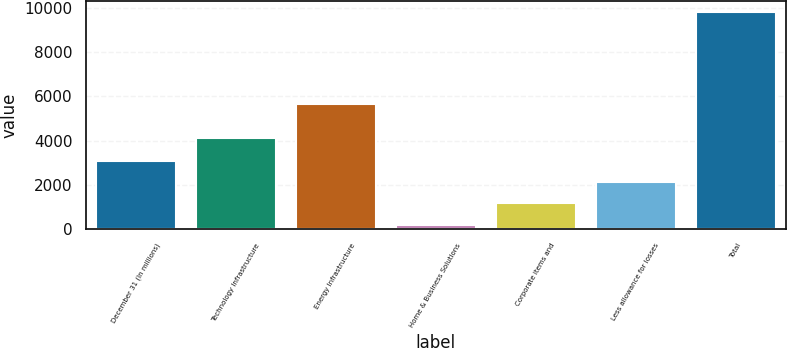Convert chart. <chart><loc_0><loc_0><loc_500><loc_500><bar_chart><fcel>December 31 (In millions)<fcel>Technology Infrastructure<fcel>Energy Infrastructure<fcel>Home & Business Solutions<fcel>Corporate items and<fcel>Less allowance for losses<fcel>Total<nl><fcel>3091.7<fcel>4110<fcel>5641<fcel>209<fcel>1169.9<fcel>2130.8<fcel>9818<nl></chart> 